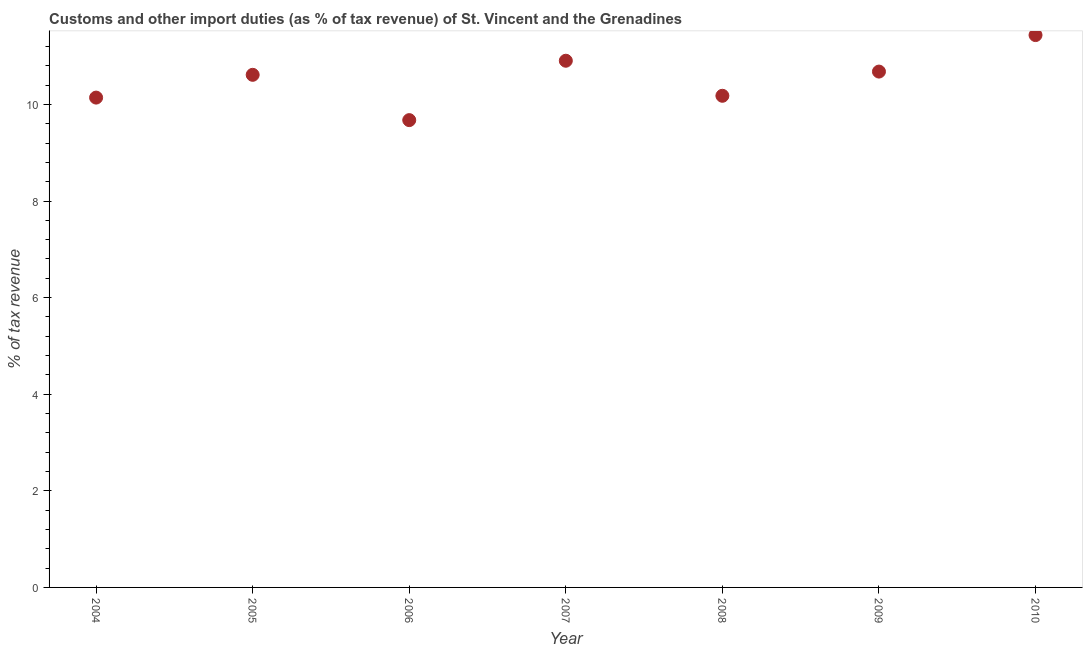What is the customs and other import duties in 2010?
Provide a succinct answer. 11.44. Across all years, what is the maximum customs and other import duties?
Your response must be concise. 11.44. Across all years, what is the minimum customs and other import duties?
Offer a terse response. 9.67. In which year was the customs and other import duties minimum?
Provide a succinct answer. 2006. What is the sum of the customs and other import duties?
Your answer should be very brief. 73.63. What is the difference between the customs and other import duties in 2004 and 2008?
Your answer should be compact. -0.04. What is the average customs and other import duties per year?
Provide a short and direct response. 10.52. What is the median customs and other import duties?
Offer a terse response. 10.61. In how many years, is the customs and other import duties greater than 2.8 %?
Your response must be concise. 7. What is the ratio of the customs and other import duties in 2008 to that in 2009?
Your answer should be compact. 0.95. What is the difference between the highest and the second highest customs and other import duties?
Your answer should be very brief. 0.53. What is the difference between the highest and the lowest customs and other import duties?
Give a very brief answer. 1.76. Does the customs and other import duties monotonically increase over the years?
Your response must be concise. No. How many dotlines are there?
Give a very brief answer. 1. How many years are there in the graph?
Keep it short and to the point. 7. What is the difference between two consecutive major ticks on the Y-axis?
Give a very brief answer. 2. Does the graph contain any zero values?
Your answer should be compact. No. Does the graph contain grids?
Offer a terse response. No. What is the title of the graph?
Your answer should be compact. Customs and other import duties (as % of tax revenue) of St. Vincent and the Grenadines. What is the label or title of the Y-axis?
Give a very brief answer. % of tax revenue. What is the % of tax revenue in 2004?
Your response must be concise. 10.14. What is the % of tax revenue in 2005?
Provide a short and direct response. 10.61. What is the % of tax revenue in 2006?
Provide a succinct answer. 9.67. What is the % of tax revenue in 2007?
Offer a terse response. 10.9. What is the % of tax revenue in 2008?
Give a very brief answer. 10.18. What is the % of tax revenue in 2009?
Offer a terse response. 10.68. What is the % of tax revenue in 2010?
Your answer should be very brief. 11.44. What is the difference between the % of tax revenue in 2004 and 2005?
Provide a succinct answer. -0.47. What is the difference between the % of tax revenue in 2004 and 2006?
Provide a succinct answer. 0.47. What is the difference between the % of tax revenue in 2004 and 2007?
Provide a short and direct response. -0.76. What is the difference between the % of tax revenue in 2004 and 2008?
Keep it short and to the point. -0.04. What is the difference between the % of tax revenue in 2004 and 2009?
Provide a succinct answer. -0.54. What is the difference between the % of tax revenue in 2004 and 2010?
Give a very brief answer. -1.29. What is the difference between the % of tax revenue in 2005 and 2006?
Your response must be concise. 0.94. What is the difference between the % of tax revenue in 2005 and 2007?
Your answer should be compact. -0.29. What is the difference between the % of tax revenue in 2005 and 2008?
Offer a very short reply. 0.43. What is the difference between the % of tax revenue in 2005 and 2009?
Offer a very short reply. -0.07. What is the difference between the % of tax revenue in 2005 and 2010?
Make the answer very short. -0.82. What is the difference between the % of tax revenue in 2006 and 2007?
Keep it short and to the point. -1.23. What is the difference between the % of tax revenue in 2006 and 2008?
Ensure brevity in your answer.  -0.5. What is the difference between the % of tax revenue in 2006 and 2009?
Provide a short and direct response. -1. What is the difference between the % of tax revenue in 2006 and 2010?
Keep it short and to the point. -1.76. What is the difference between the % of tax revenue in 2007 and 2008?
Make the answer very short. 0.73. What is the difference between the % of tax revenue in 2007 and 2009?
Your answer should be compact. 0.22. What is the difference between the % of tax revenue in 2007 and 2010?
Keep it short and to the point. -0.53. What is the difference between the % of tax revenue in 2008 and 2009?
Offer a terse response. -0.5. What is the difference between the % of tax revenue in 2008 and 2010?
Provide a succinct answer. -1.26. What is the difference between the % of tax revenue in 2009 and 2010?
Your answer should be compact. -0.76. What is the ratio of the % of tax revenue in 2004 to that in 2005?
Your answer should be compact. 0.96. What is the ratio of the % of tax revenue in 2004 to that in 2006?
Keep it short and to the point. 1.05. What is the ratio of the % of tax revenue in 2004 to that in 2008?
Provide a short and direct response. 1. What is the ratio of the % of tax revenue in 2004 to that in 2009?
Your response must be concise. 0.95. What is the ratio of the % of tax revenue in 2004 to that in 2010?
Give a very brief answer. 0.89. What is the ratio of the % of tax revenue in 2005 to that in 2006?
Offer a terse response. 1.1. What is the ratio of the % of tax revenue in 2005 to that in 2007?
Give a very brief answer. 0.97. What is the ratio of the % of tax revenue in 2005 to that in 2008?
Provide a short and direct response. 1.04. What is the ratio of the % of tax revenue in 2005 to that in 2009?
Ensure brevity in your answer.  0.99. What is the ratio of the % of tax revenue in 2005 to that in 2010?
Your answer should be compact. 0.93. What is the ratio of the % of tax revenue in 2006 to that in 2007?
Ensure brevity in your answer.  0.89. What is the ratio of the % of tax revenue in 2006 to that in 2008?
Provide a short and direct response. 0.95. What is the ratio of the % of tax revenue in 2006 to that in 2009?
Offer a terse response. 0.91. What is the ratio of the % of tax revenue in 2006 to that in 2010?
Provide a succinct answer. 0.85. What is the ratio of the % of tax revenue in 2007 to that in 2008?
Keep it short and to the point. 1.07. What is the ratio of the % of tax revenue in 2007 to that in 2009?
Provide a short and direct response. 1.02. What is the ratio of the % of tax revenue in 2007 to that in 2010?
Keep it short and to the point. 0.95. What is the ratio of the % of tax revenue in 2008 to that in 2009?
Provide a succinct answer. 0.95. What is the ratio of the % of tax revenue in 2008 to that in 2010?
Keep it short and to the point. 0.89. What is the ratio of the % of tax revenue in 2009 to that in 2010?
Make the answer very short. 0.93. 